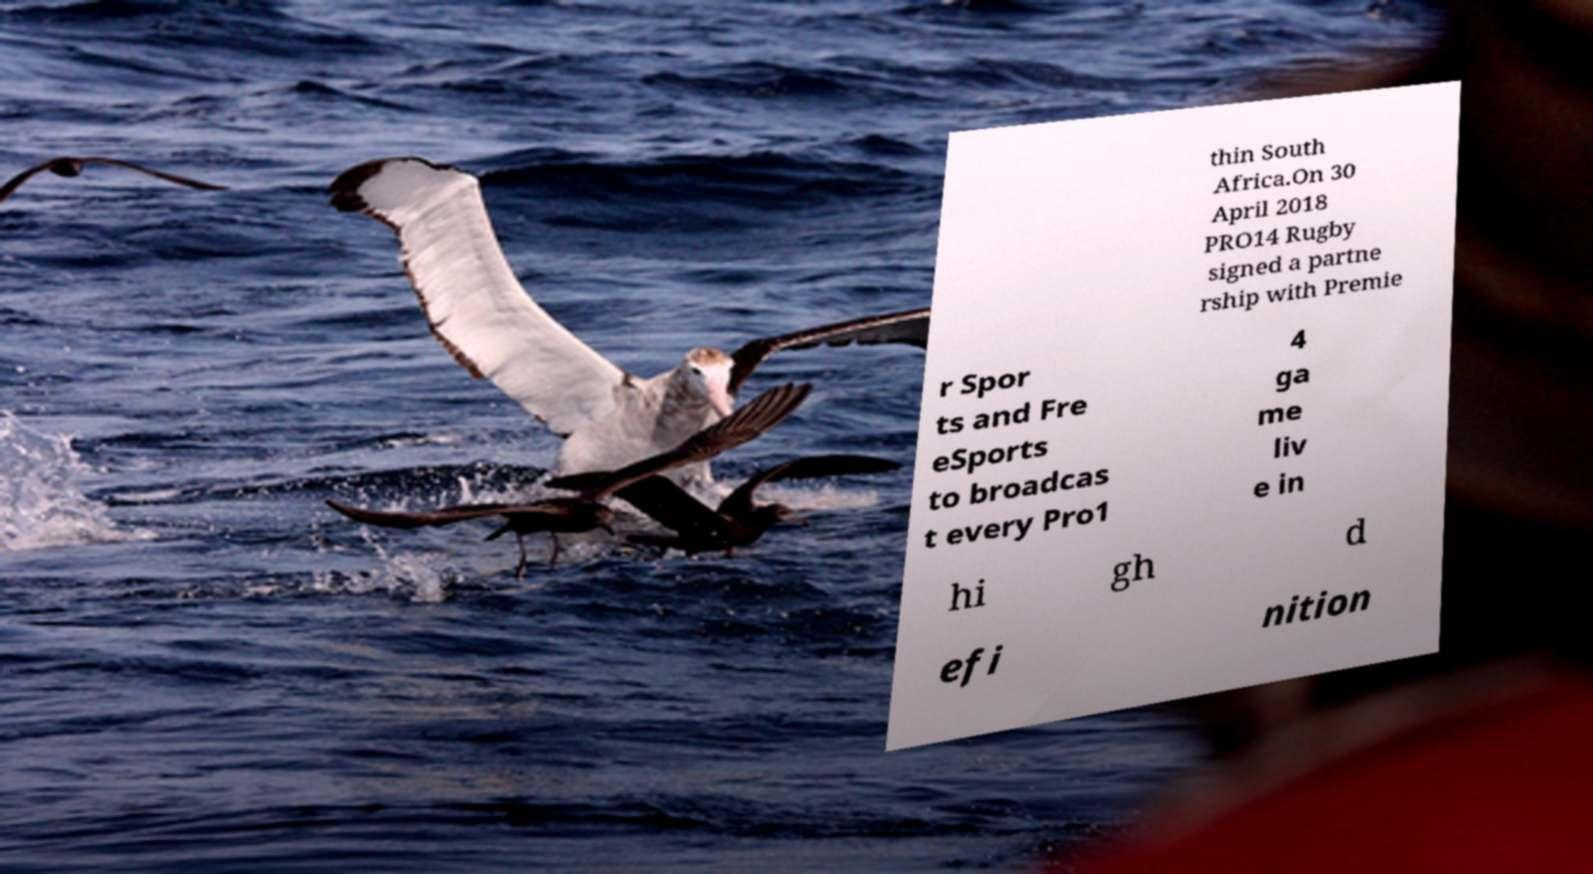Please identify and transcribe the text found in this image. thin South Africa.On 30 April 2018 PRO14 Rugby signed a partne rship with Premie r Spor ts and Fre eSports to broadcas t every Pro1 4 ga me liv e in hi gh d efi nition 